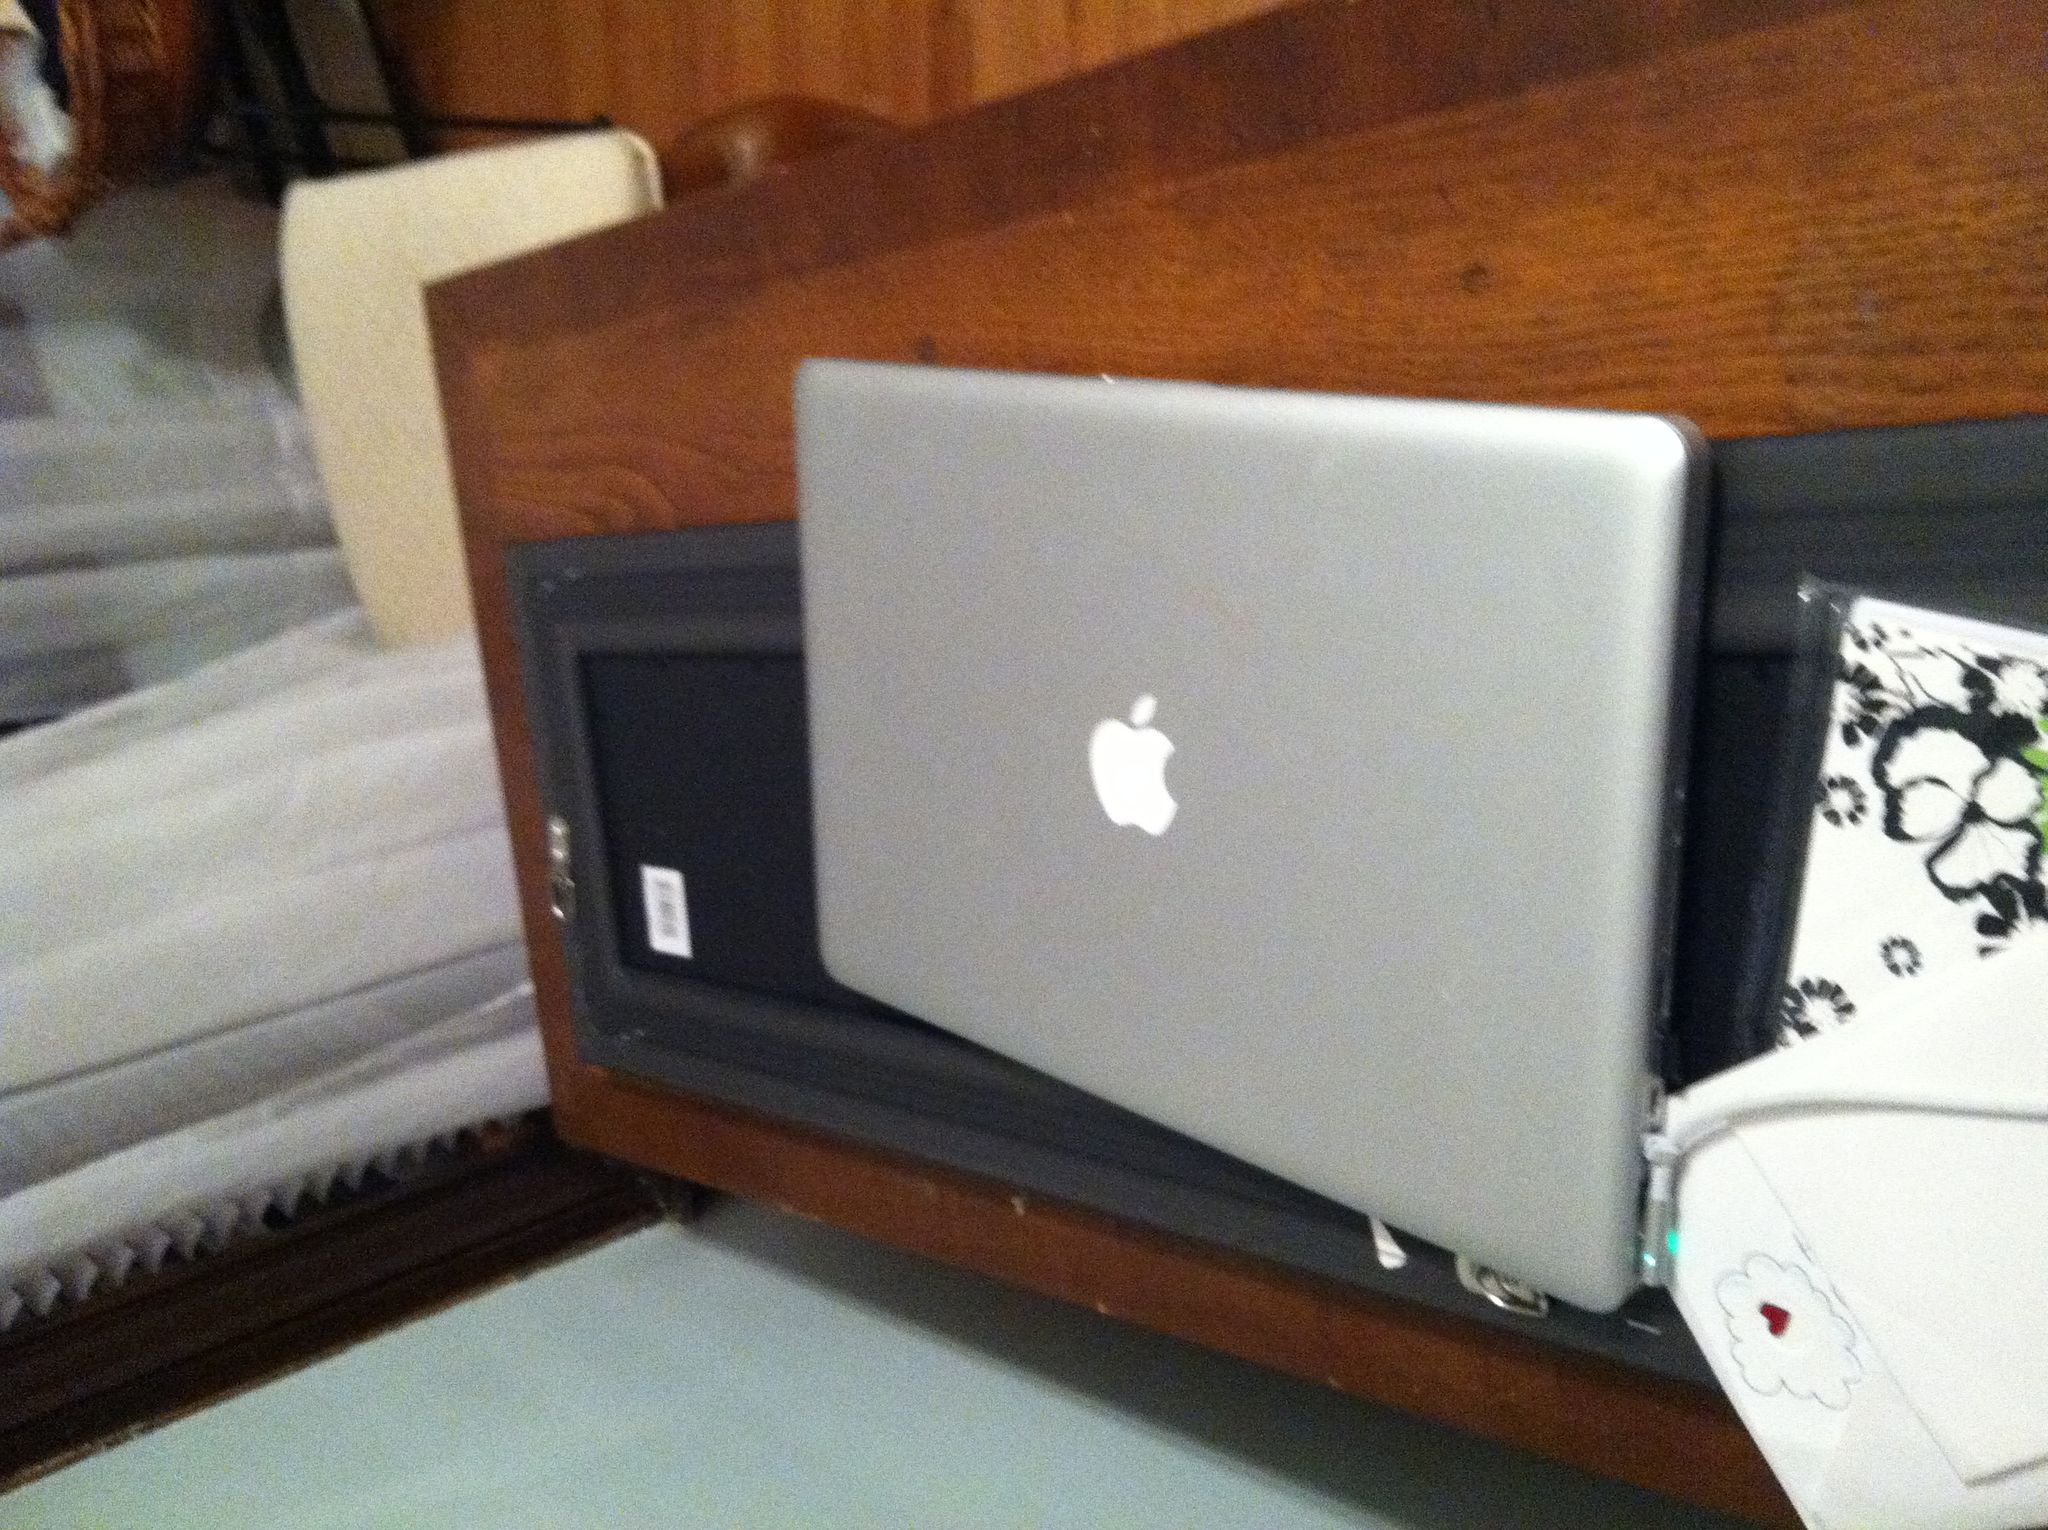What kind of machine is this, and who makes it? from Vizwiz apple ibook 